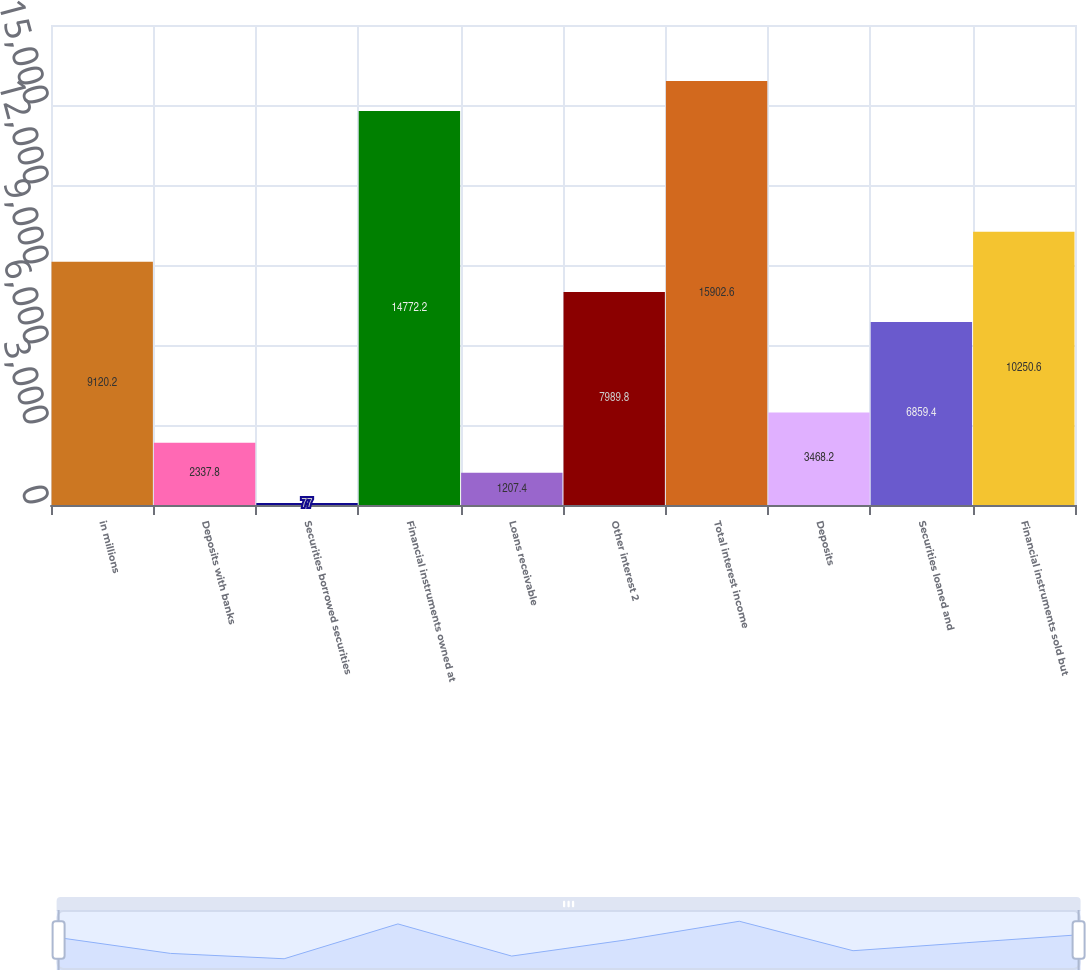<chart> <loc_0><loc_0><loc_500><loc_500><bar_chart><fcel>in millions<fcel>Deposits with banks<fcel>Securities borrowed securities<fcel>Financial instruments owned at<fcel>Loans receivable<fcel>Other interest 2<fcel>Total interest income<fcel>Deposits<fcel>Securities loaned and<fcel>Financial instruments sold but<nl><fcel>9120.2<fcel>2337.8<fcel>77<fcel>14772.2<fcel>1207.4<fcel>7989.8<fcel>15902.6<fcel>3468.2<fcel>6859.4<fcel>10250.6<nl></chart> 